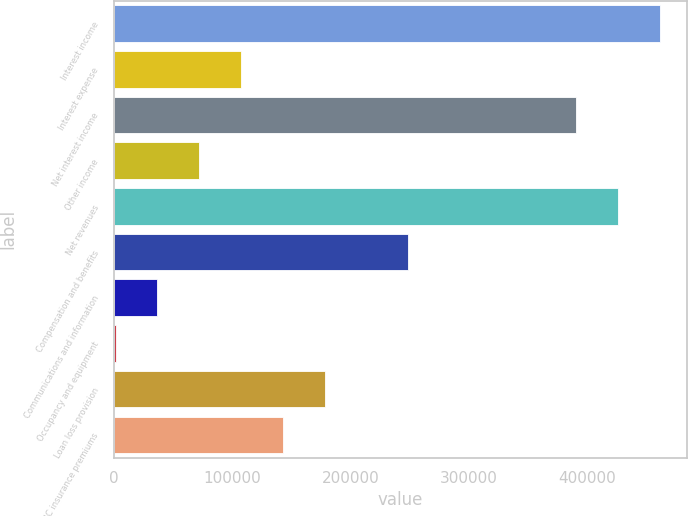Convert chart to OTSL. <chart><loc_0><loc_0><loc_500><loc_500><bar_chart><fcel>Interest income<fcel>Interest expense<fcel>Net interest income<fcel>Other income<fcel>Net revenues<fcel>Compensation and benefits<fcel>Communications and information<fcel>Occupancy and equipment<fcel>Loan loss provision<fcel>FDIC insurance premiums<nl><fcel>461513<fcel>107483<fcel>390707<fcel>72080<fcel>426110<fcel>249095<fcel>36677<fcel>1274<fcel>178289<fcel>142886<nl></chart> 